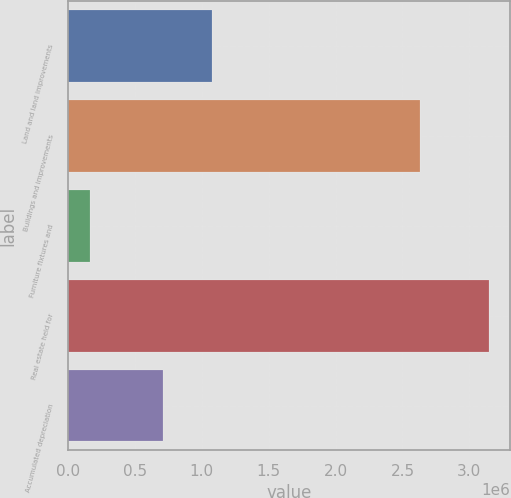Convert chart to OTSL. <chart><loc_0><loc_0><loc_500><loc_500><bar_chart><fcel>Land and land improvements<fcel>Buildings and improvements<fcel>Furniture fixtures and<fcel>Real estate held for<fcel>Accumulated depreciation<nl><fcel>1.07725e+06<fcel>2.62767e+06<fcel>163450<fcel>3.14537e+06<fcel>708233<nl></chart> 